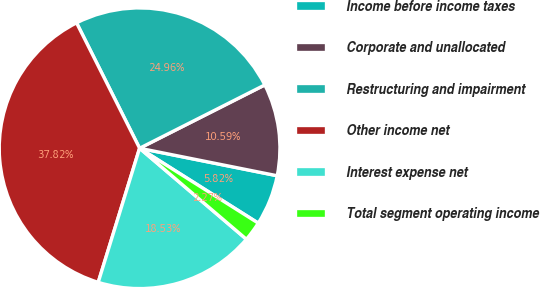<chart> <loc_0><loc_0><loc_500><loc_500><pie_chart><fcel>Income before income taxes<fcel>Corporate and unallocated<fcel>Restructuring and impairment<fcel>Other income net<fcel>Interest expense net<fcel>Total segment operating income<nl><fcel>5.82%<fcel>10.59%<fcel>24.96%<fcel>37.82%<fcel>18.53%<fcel>2.27%<nl></chart> 